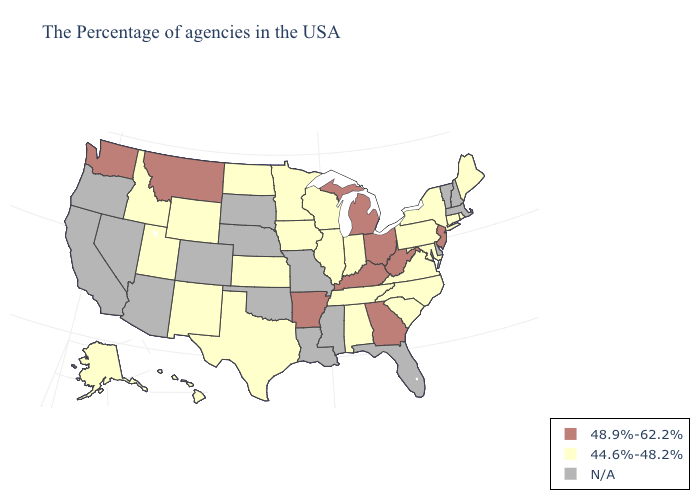What is the value of Ohio?
Quick response, please. 48.9%-62.2%. Name the states that have a value in the range 48.9%-62.2%?
Quick response, please. New Jersey, West Virginia, Ohio, Georgia, Michigan, Kentucky, Arkansas, Montana, Washington. Does West Virginia have the lowest value in the South?
Concise answer only. No. Name the states that have a value in the range N/A?
Be succinct. Massachusetts, New Hampshire, Vermont, Delaware, Florida, Mississippi, Louisiana, Missouri, Nebraska, Oklahoma, South Dakota, Colorado, Arizona, Nevada, California, Oregon. Is the legend a continuous bar?
Concise answer only. No. Does the first symbol in the legend represent the smallest category?
Give a very brief answer. No. Does the map have missing data?
Write a very short answer. Yes. Name the states that have a value in the range N/A?
Keep it brief. Massachusetts, New Hampshire, Vermont, Delaware, Florida, Mississippi, Louisiana, Missouri, Nebraska, Oklahoma, South Dakota, Colorado, Arizona, Nevada, California, Oregon. Name the states that have a value in the range 48.9%-62.2%?
Be succinct. New Jersey, West Virginia, Ohio, Georgia, Michigan, Kentucky, Arkansas, Montana, Washington. What is the value of Arkansas?
Give a very brief answer. 48.9%-62.2%. Name the states that have a value in the range 44.6%-48.2%?
Answer briefly. Maine, Rhode Island, Connecticut, New York, Maryland, Pennsylvania, Virginia, North Carolina, South Carolina, Indiana, Alabama, Tennessee, Wisconsin, Illinois, Minnesota, Iowa, Kansas, Texas, North Dakota, Wyoming, New Mexico, Utah, Idaho, Alaska, Hawaii. Is the legend a continuous bar?
Short answer required. No. Which states hav the highest value in the MidWest?
Give a very brief answer. Ohio, Michigan. Does Montana have the lowest value in the West?
Short answer required. No. Name the states that have a value in the range 44.6%-48.2%?
Keep it brief. Maine, Rhode Island, Connecticut, New York, Maryland, Pennsylvania, Virginia, North Carolina, South Carolina, Indiana, Alabama, Tennessee, Wisconsin, Illinois, Minnesota, Iowa, Kansas, Texas, North Dakota, Wyoming, New Mexico, Utah, Idaho, Alaska, Hawaii. 